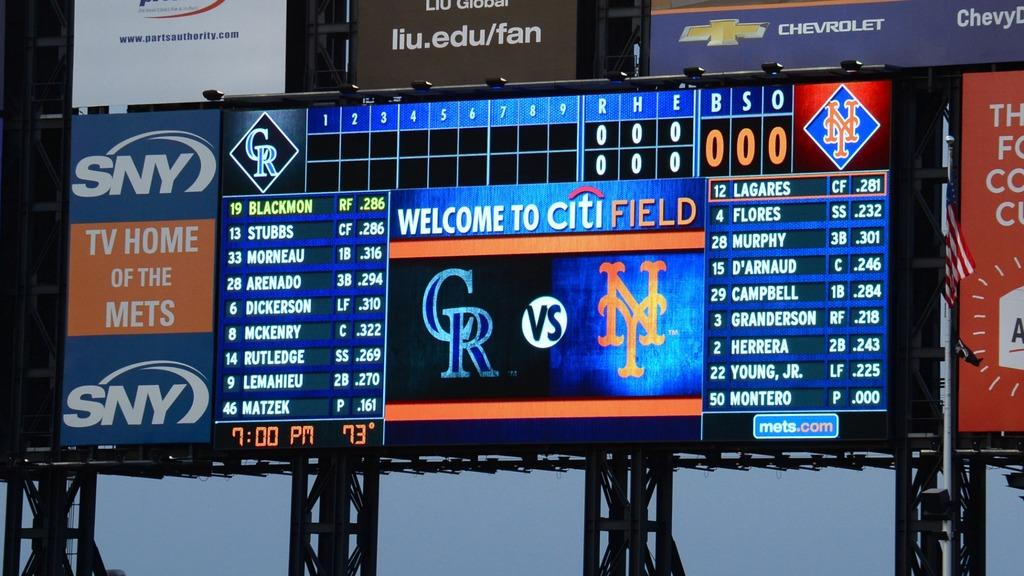<image>
Give a short and clear explanation of the subsequent image. A sign says "welcome to Citi Field" and shows which teams are playing. 